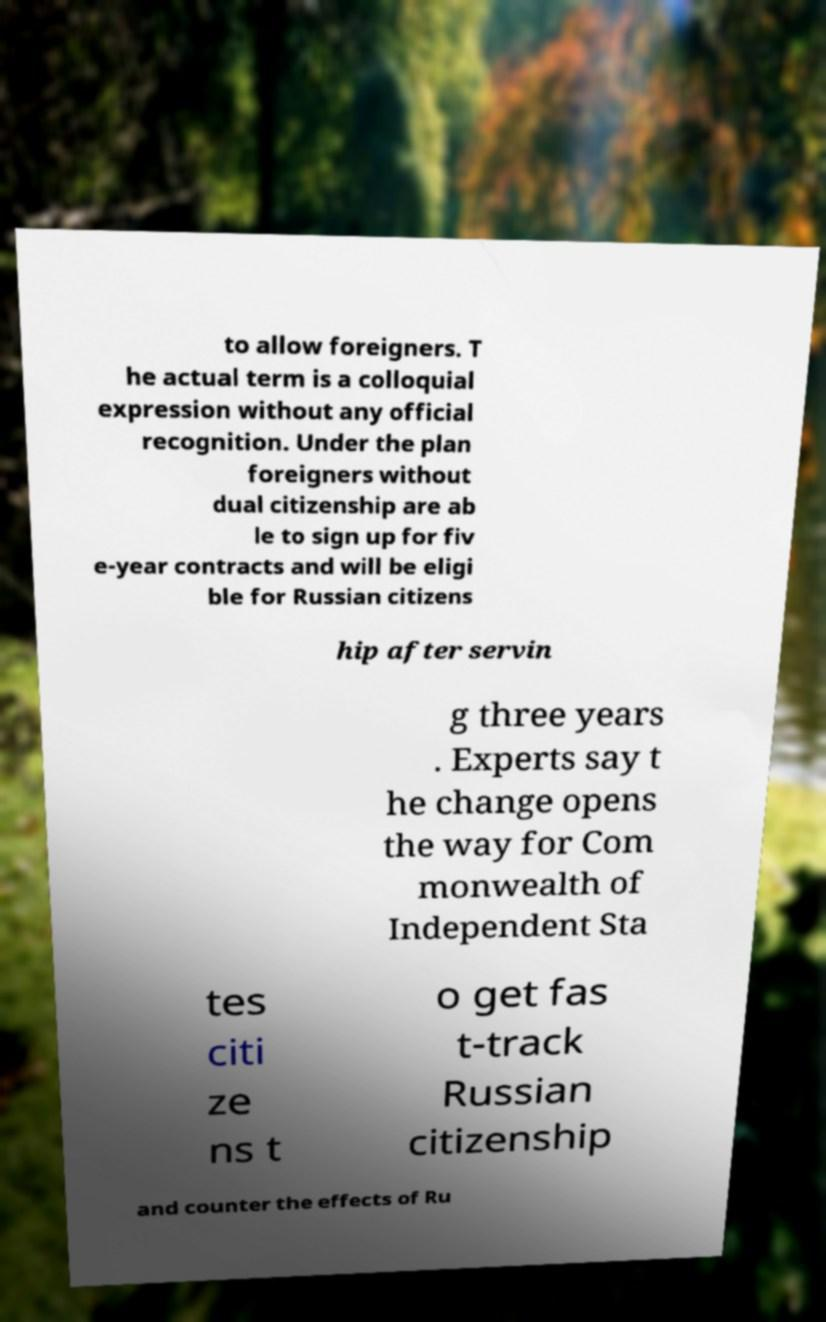Can you accurately transcribe the text from the provided image for me? to allow foreigners. T he actual term is a colloquial expression without any official recognition. Under the plan foreigners without dual citizenship are ab le to sign up for fiv e-year contracts and will be eligi ble for Russian citizens hip after servin g three years . Experts say t he change opens the way for Com monwealth of Independent Sta tes citi ze ns t o get fas t-track Russian citizenship and counter the effects of Ru 